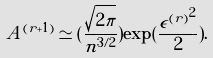Convert formula to latex. <formula><loc_0><loc_0><loc_500><loc_500>A ^ { ( r + 1 ) } \simeq ( \frac { \sqrt { 2 \pi } } { n ^ { 3 / 2 } } ) \exp ( \frac { { \epsilon ^ { ( r ) } } ^ { 2 } } { 2 } ) .</formula> 